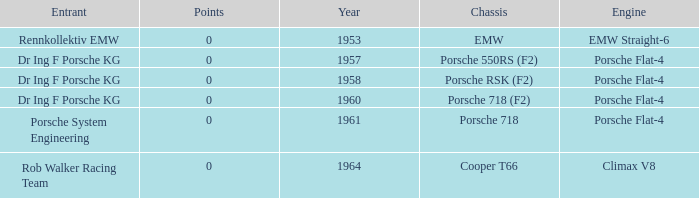Which engine did dr ing f porsche kg use with the porsche rsk (f2) chassis? Porsche Flat-4. 